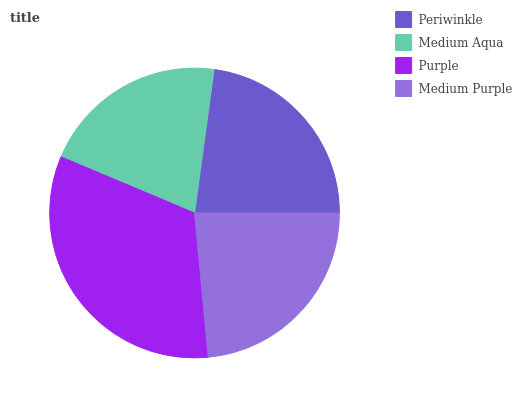Is Medium Aqua the minimum?
Answer yes or no. Yes. Is Purple the maximum?
Answer yes or no. Yes. Is Purple the minimum?
Answer yes or no. No. Is Medium Aqua the maximum?
Answer yes or no. No. Is Purple greater than Medium Aqua?
Answer yes or no. Yes. Is Medium Aqua less than Purple?
Answer yes or no. Yes. Is Medium Aqua greater than Purple?
Answer yes or no. No. Is Purple less than Medium Aqua?
Answer yes or no. No. Is Medium Purple the high median?
Answer yes or no. Yes. Is Periwinkle the low median?
Answer yes or no. Yes. Is Medium Aqua the high median?
Answer yes or no. No. Is Purple the low median?
Answer yes or no. No. 